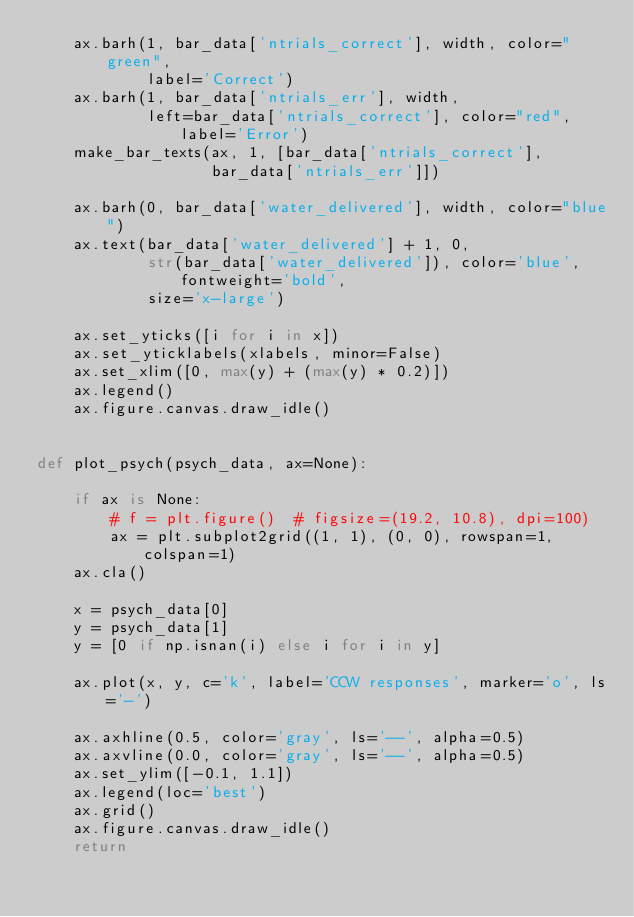Convert code to text. <code><loc_0><loc_0><loc_500><loc_500><_Python_>    ax.barh(1, bar_data['ntrials_correct'], width, color="green",
            label='Correct')
    ax.barh(1, bar_data['ntrials_err'], width,
            left=bar_data['ntrials_correct'], color="red", label='Error')
    make_bar_texts(ax, 1, [bar_data['ntrials_correct'],
                   bar_data['ntrials_err']])

    ax.barh(0, bar_data['water_delivered'], width, color="blue")
    ax.text(bar_data['water_delivered'] + 1, 0,
            str(bar_data['water_delivered']), color='blue', fontweight='bold',
            size='x-large')

    ax.set_yticks([i for i in x])
    ax.set_yticklabels(xlabels, minor=False)
    ax.set_xlim([0, max(y) + (max(y) * 0.2)])
    ax.legend()
    ax.figure.canvas.draw_idle()


def plot_psych(psych_data, ax=None):

    if ax is None:
        # f = plt.figure()  # figsize=(19.2, 10.8), dpi=100)
        ax = plt.subplot2grid((1, 1), (0, 0), rowspan=1, colspan=1)
    ax.cla()

    x = psych_data[0]
    y = psych_data[1]
    y = [0 if np.isnan(i) else i for i in y]

    ax.plot(x, y, c='k', label='CCW responses', marker='o', ls='-')

    ax.axhline(0.5, color='gray', ls='--', alpha=0.5)
    ax.axvline(0.0, color='gray', ls='--', alpha=0.5)
    ax.set_ylim([-0.1, 1.1])
    ax.legend(loc='best')
    ax.grid()
    ax.figure.canvas.draw_idle()
    return

</code> 